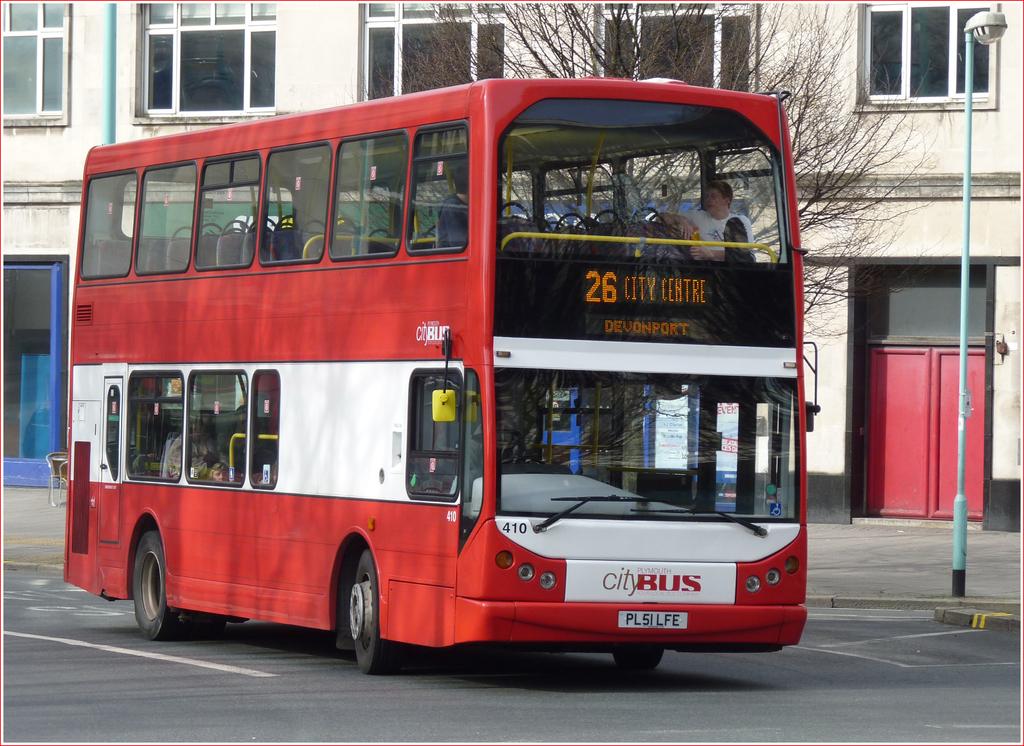What bus number is this double decker?
Offer a terse response. 26. What number bus is this?
Give a very brief answer. 26. 